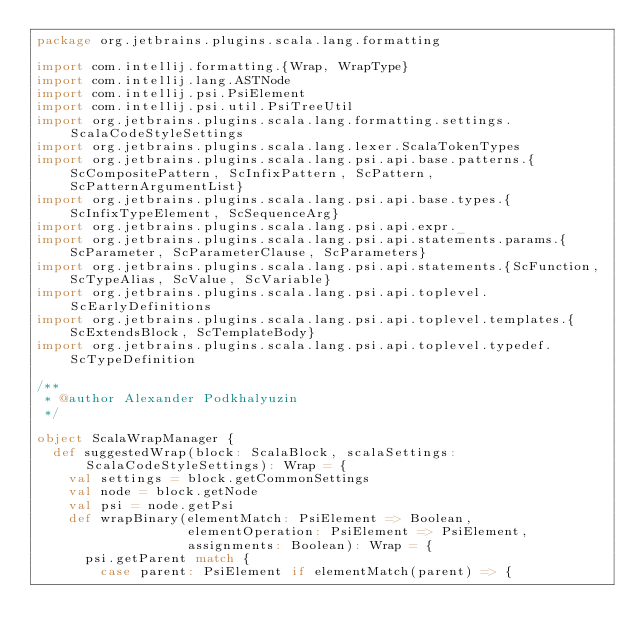<code> <loc_0><loc_0><loc_500><loc_500><_Scala_>package org.jetbrains.plugins.scala.lang.formatting

import com.intellij.formatting.{Wrap, WrapType}
import com.intellij.lang.ASTNode
import com.intellij.psi.PsiElement
import com.intellij.psi.util.PsiTreeUtil
import org.jetbrains.plugins.scala.lang.formatting.settings.ScalaCodeStyleSettings
import org.jetbrains.plugins.scala.lang.lexer.ScalaTokenTypes
import org.jetbrains.plugins.scala.lang.psi.api.base.patterns.{ScCompositePattern, ScInfixPattern, ScPattern, ScPatternArgumentList}
import org.jetbrains.plugins.scala.lang.psi.api.base.types.{ScInfixTypeElement, ScSequenceArg}
import org.jetbrains.plugins.scala.lang.psi.api.expr._
import org.jetbrains.plugins.scala.lang.psi.api.statements.params.{ScParameter, ScParameterClause, ScParameters}
import org.jetbrains.plugins.scala.lang.psi.api.statements.{ScFunction, ScTypeAlias, ScValue, ScVariable}
import org.jetbrains.plugins.scala.lang.psi.api.toplevel.ScEarlyDefinitions
import org.jetbrains.plugins.scala.lang.psi.api.toplevel.templates.{ScExtendsBlock, ScTemplateBody}
import org.jetbrains.plugins.scala.lang.psi.api.toplevel.typedef.ScTypeDefinition

/**
 * @author Alexander Podkhalyuzin
 */

object ScalaWrapManager {
  def suggestedWrap(block: ScalaBlock, scalaSettings: ScalaCodeStyleSettings): Wrap = {
    val settings = block.getCommonSettings
    val node = block.getNode
    val psi = node.getPsi
    def wrapBinary(elementMatch: PsiElement => Boolean,
                   elementOperation: PsiElement => PsiElement,
                   assignments: Boolean): Wrap = {
      psi.getParent match {
        case parent: PsiElement if elementMatch(parent) => {</code> 